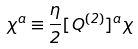Convert formula to latex. <formula><loc_0><loc_0><loc_500><loc_500>\chi ^ { a } \equiv \frac { \eta } { 2 } [ Q ^ { ( 2 ) } ] ^ { a } \chi</formula> 